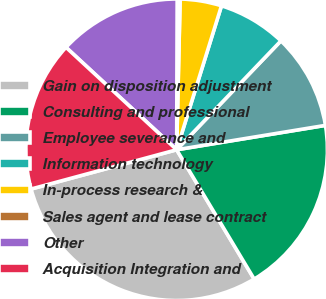<chart> <loc_0><loc_0><loc_500><loc_500><pie_chart><fcel>Gain on disposition adjustment<fcel>Consulting and professional<fcel>Employee severance and<fcel>Information technology<fcel>In-process research &<fcel>Sales agent and lease contract<fcel>Other<fcel>Acquisition Integration and<nl><fcel>29.4%<fcel>18.99%<fcel>10.26%<fcel>7.35%<fcel>4.44%<fcel>0.31%<fcel>13.17%<fcel>16.08%<nl></chart> 